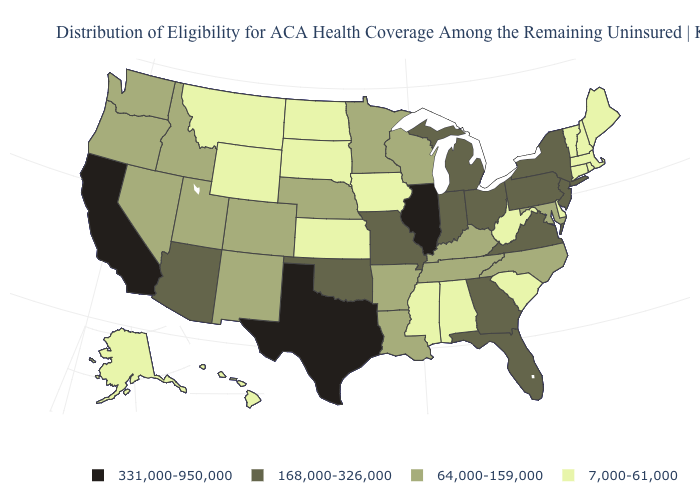Does Hawaii have the lowest value in the USA?
Answer briefly. Yes. Which states hav the highest value in the Northeast?
Answer briefly. New Jersey, New York, Pennsylvania. Name the states that have a value in the range 7,000-61,000?
Keep it brief. Alabama, Alaska, Connecticut, Delaware, Hawaii, Iowa, Kansas, Maine, Massachusetts, Mississippi, Montana, New Hampshire, North Dakota, Rhode Island, South Carolina, South Dakota, Vermont, West Virginia, Wyoming. Name the states that have a value in the range 331,000-950,000?
Concise answer only. California, Illinois, Texas. Does Alabama have the lowest value in the South?
Write a very short answer. Yes. What is the value of New York?
Concise answer only. 168,000-326,000. What is the highest value in the Northeast ?
Quick response, please. 168,000-326,000. Among the states that border Texas , does Oklahoma have the highest value?
Be succinct. Yes. Which states have the highest value in the USA?
Answer briefly. California, Illinois, Texas. What is the value of Mississippi?
Quick response, please. 7,000-61,000. Which states have the lowest value in the USA?
Quick response, please. Alabama, Alaska, Connecticut, Delaware, Hawaii, Iowa, Kansas, Maine, Massachusetts, Mississippi, Montana, New Hampshire, North Dakota, Rhode Island, South Carolina, South Dakota, Vermont, West Virginia, Wyoming. Does Illinois have the highest value in the MidWest?
Give a very brief answer. Yes. Does Montana have a higher value than Wisconsin?
Answer briefly. No. Name the states that have a value in the range 7,000-61,000?
Keep it brief. Alabama, Alaska, Connecticut, Delaware, Hawaii, Iowa, Kansas, Maine, Massachusetts, Mississippi, Montana, New Hampshire, North Dakota, Rhode Island, South Carolina, South Dakota, Vermont, West Virginia, Wyoming. Name the states that have a value in the range 7,000-61,000?
Answer briefly. Alabama, Alaska, Connecticut, Delaware, Hawaii, Iowa, Kansas, Maine, Massachusetts, Mississippi, Montana, New Hampshire, North Dakota, Rhode Island, South Carolina, South Dakota, Vermont, West Virginia, Wyoming. 